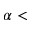<formula> <loc_0><loc_0><loc_500><loc_500>\alpha <</formula> 